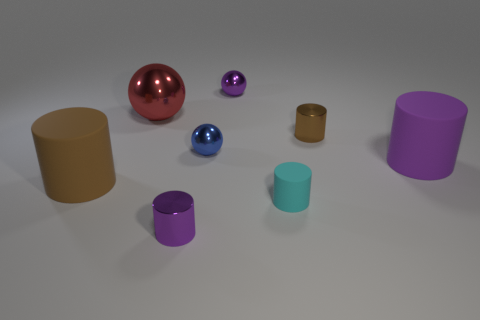Subtract all cyan cylinders. How many cylinders are left? 4 Subtract all tiny purple metal cylinders. How many cylinders are left? 4 Subtract all yellow cylinders. Subtract all cyan blocks. How many cylinders are left? 5 Add 2 large rubber objects. How many objects exist? 10 Subtract all balls. How many objects are left? 5 Subtract all matte cylinders. Subtract all purple metal spheres. How many objects are left? 4 Add 8 red balls. How many red balls are left? 9 Add 8 red rubber cylinders. How many red rubber cylinders exist? 8 Subtract 0 blue blocks. How many objects are left? 8 